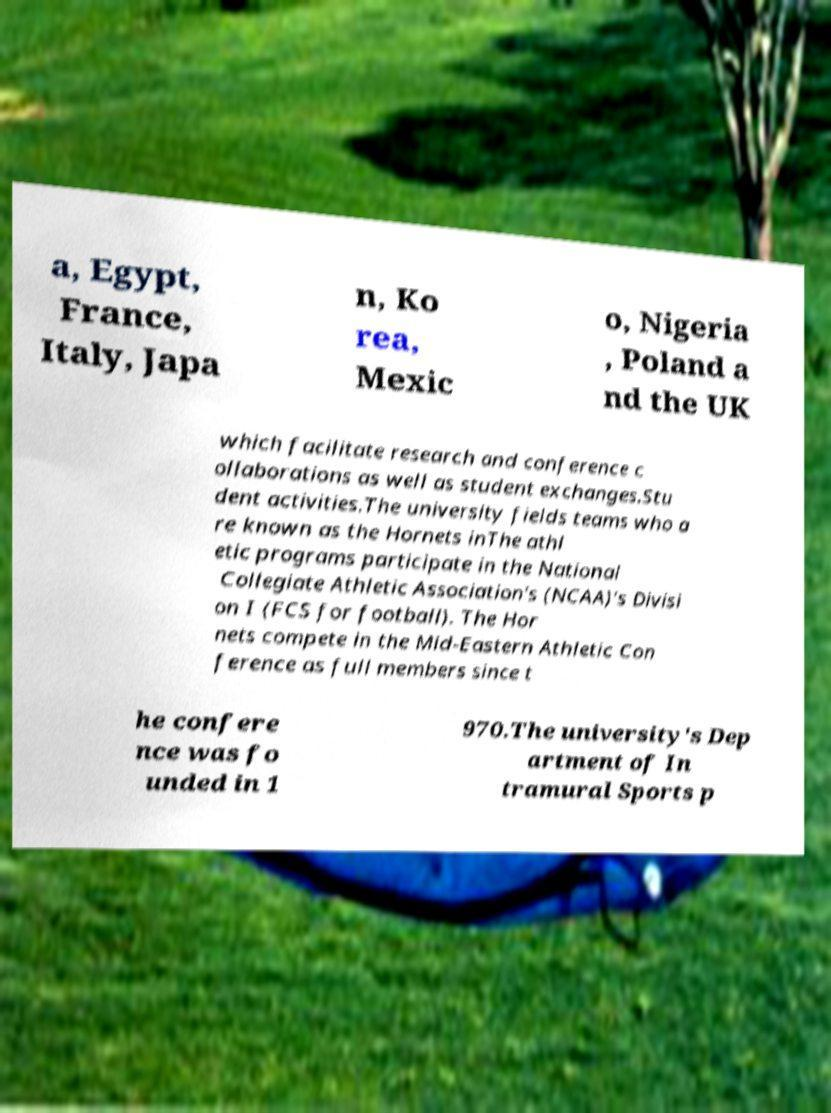Please identify and transcribe the text found in this image. a, Egypt, France, Italy, Japa n, Ko rea, Mexic o, Nigeria , Poland a nd the UK which facilitate research and conference c ollaborations as well as student exchanges.Stu dent activities.The university fields teams who a re known as the Hornets inThe athl etic programs participate in the National Collegiate Athletic Association's (NCAA)'s Divisi on I (FCS for football). The Hor nets compete in the Mid-Eastern Athletic Con ference as full members since t he confere nce was fo unded in 1 970.The university's Dep artment of In tramural Sports p 